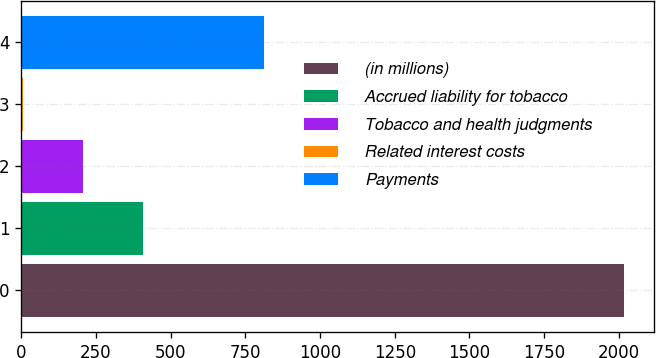Convert chart. <chart><loc_0><loc_0><loc_500><loc_500><bar_chart><fcel>(in millions)<fcel>Accrued liability for tobacco<fcel>Tobacco and health judgments<fcel>Related interest costs<fcel>Payments<nl><fcel>2016<fcel>408.8<fcel>207.9<fcel>7<fcel>810.6<nl></chart> 